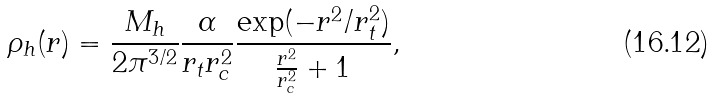<formula> <loc_0><loc_0><loc_500><loc_500>\rho _ { h } ( r ) = \frac { M _ { h } } { 2 \pi ^ { 3 / 2 } } \frac { \alpha } { r _ { t } r ^ { 2 } _ { c } } \frac { \exp ( - r ^ { 2 } / r ^ { 2 } _ { t } ) } { \frac { r ^ { 2 } } { r ^ { 2 } _ { c } } + 1 } ,</formula> 